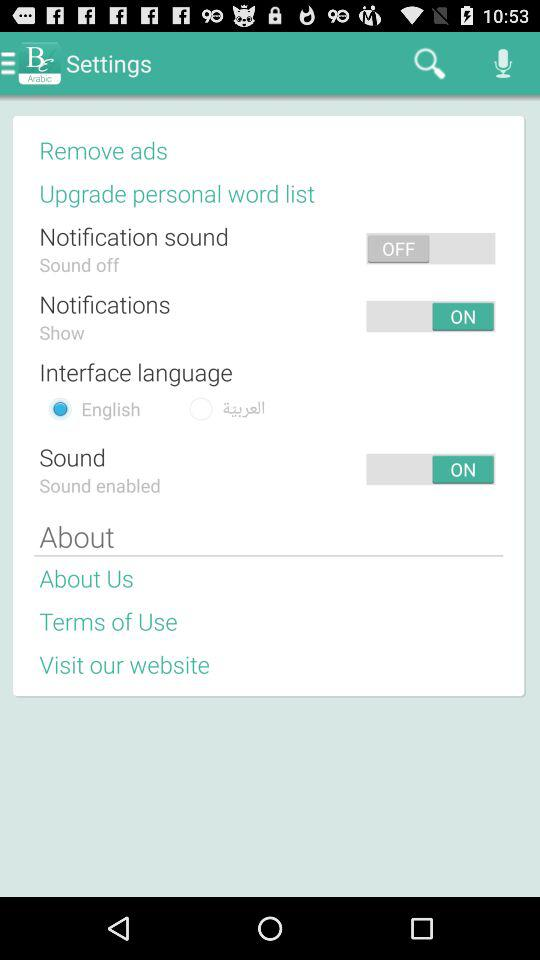What is the interface language selected? The selected interface language is "English". 